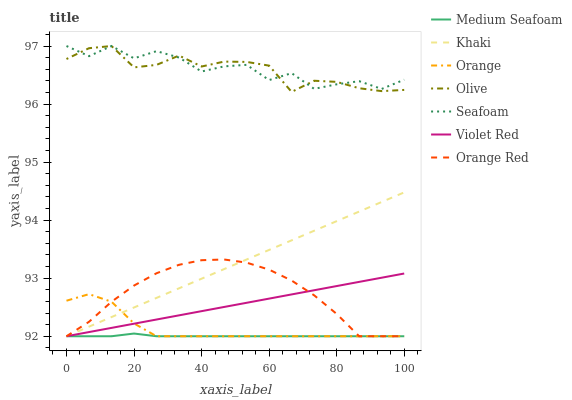Does Medium Seafoam have the minimum area under the curve?
Answer yes or no. Yes. Does Seafoam have the maximum area under the curve?
Answer yes or no. Yes. Does Khaki have the minimum area under the curve?
Answer yes or no. No. Does Khaki have the maximum area under the curve?
Answer yes or no. No. Is Khaki the smoothest?
Answer yes or no. Yes. Is Seafoam the roughest?
Answer yes or no. Yes. Is Seafoam the smoothest?
Answer yes or no. No. Is Khaki the roughest?
Answer yes or no. No. Does Violet Red have the lowest value?
Answer yes or no. Yes. Does Seafoam have the lowest value?
Answer yes or no. No. Does Olive have the highest value?
Answer yes or no. Yes. Does Khaki have the highest value?
Answer yes or no. No. Is Violet Red less than Seafoam?
Answer yes or no. Yes. Is Seafoam greater than Orange?
Answer yes or no. Yes. Does Violet Red intersect Medium Seafoam?
Answer yes or no. Yes. Is Violet Red less than Medium Seafoam?
Answer yes or no. No. Is Violet Red greater than Medium Seafoam?
Answer yes or no. No. Does Violet Red intersect Seafoam?
Answer yes or no. No. 